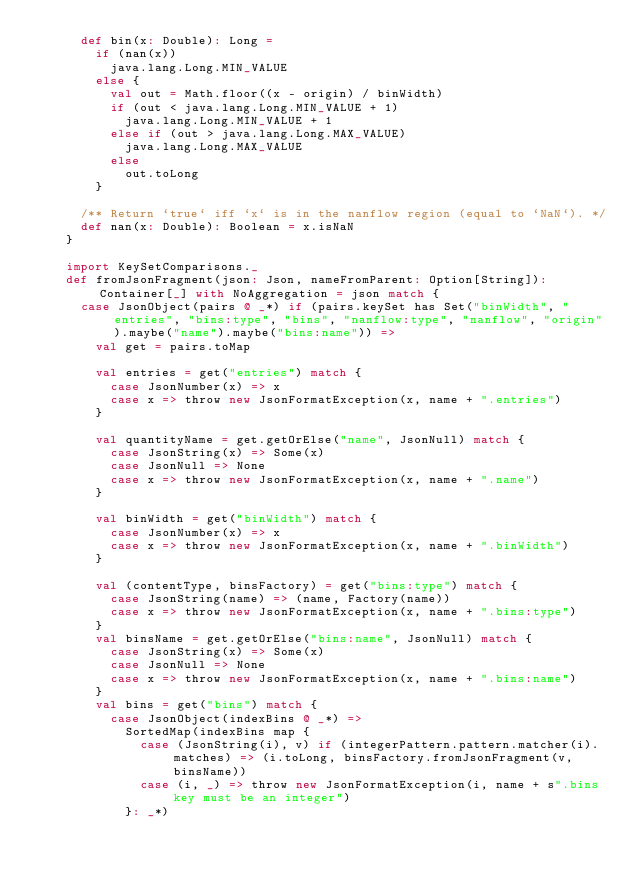Convert code to text. <code><loc_0><loc_0><loc_500><loc_500><_Scala_>      def bin(x: Double): Long =
        if (nan(x))
          java.lang.Long.MIN_VALUE
        else {
          val out = Math.floor((x - origin) / binWidth)
          if (out < java.lang.Long.MIN_VALUE + 1)
            java.lang.Long.MIN_VALUE + 1
          else if (out > java.lang.Long.MAX_VALUE)
            java.lang.Long.MAX_VALUE
          else
            out.toLong
        }

      /** Return `true` iff `x` is in the nanflow region (equal to `NaN`). */
      def nan(x: Double): Boolean = x.isNaN
    }

    import KeySetComparisons._
    def fromJsonFragment(json: Json, nameFromParent: Option[String]): Container[_] with NoAggregation = json match {
      case JsonObject(pairs @ _*) if (pairs.keySet has Set("binWidth", "entries", "bins:type", "bins", "nanflow:type", "nanflow", "origin").maybe("name").maybe("bins:name")) =>
        val get = pairs.toMap

        val entries = get("entries") match {
          case JsonNumber(x) => x
          case x => throw new JsonFormatException(x, name + ".entries")
        }

        val quantityName = get.getOrElse("name", JsonNull) match {
          case JsonString(x) => Some(x)
          case JsonNull => None
          case x => throw new JsonFormatException(x, name + ".name")
        }

        val binWidth = get("binWidth") match {
          case JsonNumber(x) => x
          case x => throw new JsonFormatException(x, name + ".binWidth")
        }

        val (contentType, binsFactory) = get("bins:type") match {
          case JsonString(name) => (name, Factory(name))
          case x => throw new JsonFormatException(x, name + ".bins:type")
        }
        val binsName = get.getOrElse("bins:name", JsonNull) match {
          case JsonString(x) => Some(x)
          case JsonNull => None
          case x => throw new JsonFormatException(x, name + ".bins:name")
        }
        val bins = get("bins") match {
          case JsonObject(indexBins @ _*) =>
            SortedMap(indexBins map {
              case (JsonString(i), v) if (integerPattern.pattern.matcher(i).matches) => (i.toLong, binsFactory.fromJsonFragment(v, binsName))
              case (i, _) => throw new JsonFormatException(i, name + s".bins key must be an integer")
            }: _*)</code> 